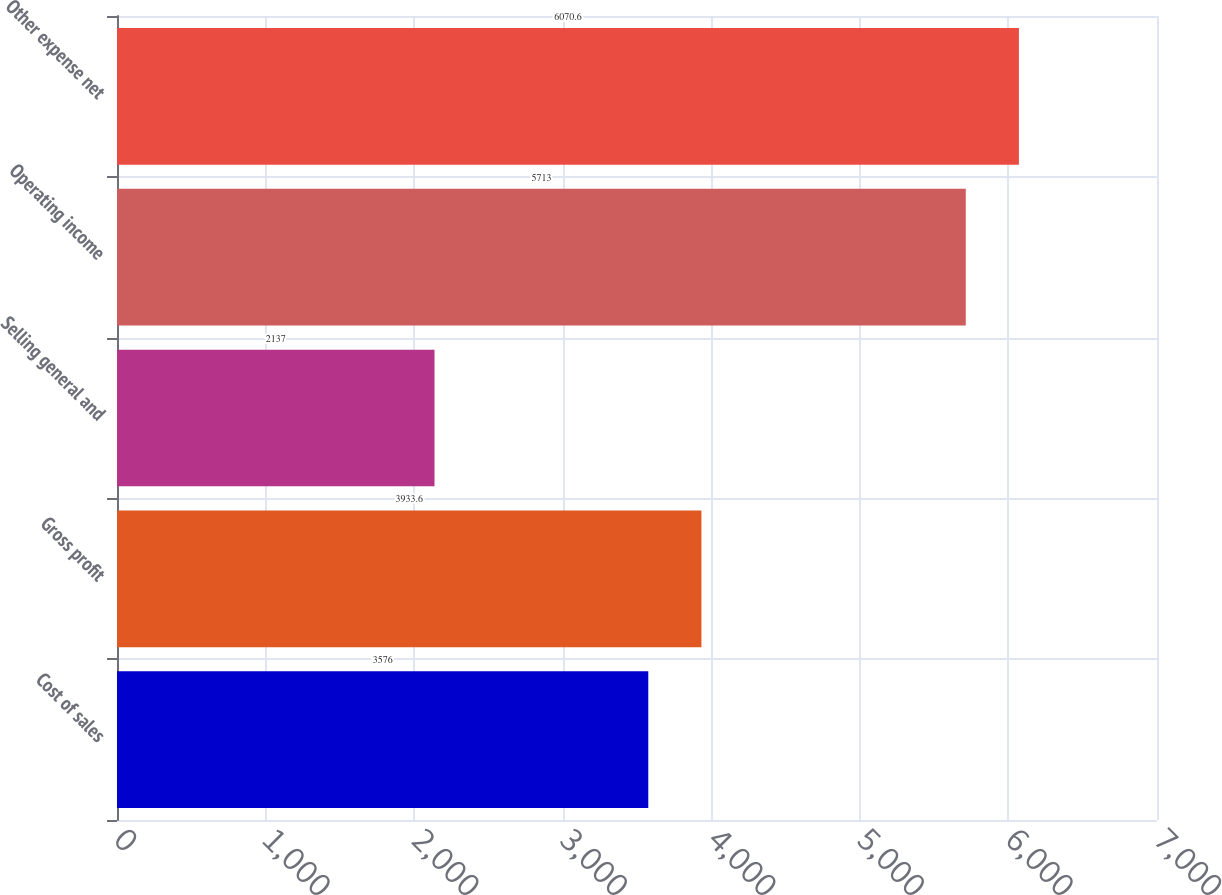<chart> <loc_0><loc_0><loc_500><loc_500><bar_chart><fcel>Cost of sales<fcel>Gross profit<fcel>Selling general and<fcel>Operating income<fcel>Other expense net<nl><fcel>3576<fcel>3933.6<fcel>2137<fcel>5713<fcel>6070.6<nl></chart> 